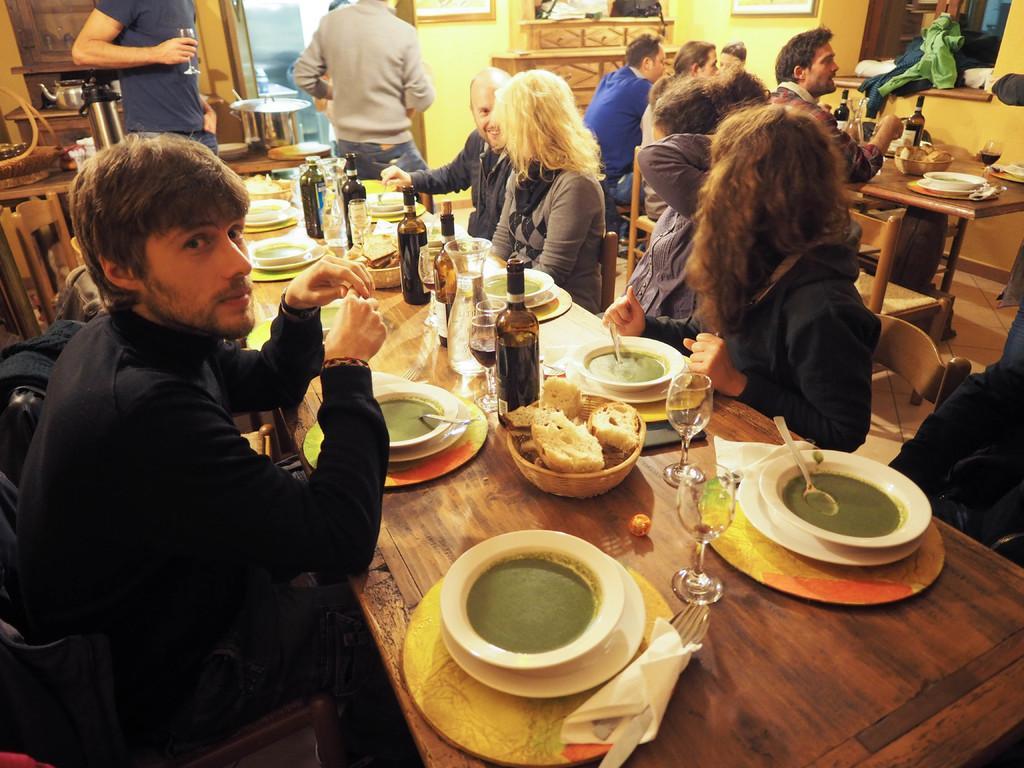Could you give a brief overview of what you see in this image? In this picture we can see few persons sitting on chairs in front of a table and on the table we can see dishes, glasses, tissue papers, spoons and forks and bottles. This is a window. Here we can see few persons standing. We can see a wall in yellow colour. 